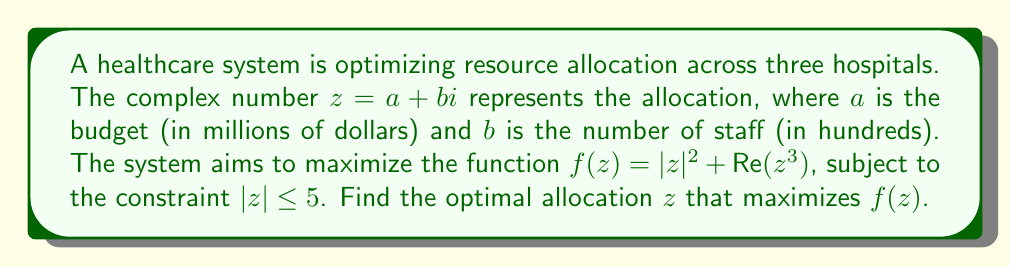Teach me how to tackle this problem. To solve this optimization problem, we'll follow these steps:

1) The function to maximize is $f(z) = |z|^2 + \text{Re}(z^3)$.

2) We can express $z$ in polar form: $z = re^{i\theta}$, where $r = |z|$ and $0 \leq r \leq 5$.

3) Substituting this into our function:

   $f(z) = r^2 + \text{Re}(r^3e^{3i\theta}) = r^2 + r^3\cos(3\theta)$

4) To find the maximum, we need to find the critical points by taking partial derivatives:

   $\frac{\partial f}{\partial r} = 2r + 3r^2\cos(3\theta) = 0$
   $\frac{\partial f}{\partial \theta} = -3r^3\sin(3\theta) = 0$

5) From the second equation, either $r = 0$ (which is not optimal) or $\sin(3\theta) = 0$. This means $3\theta = 0, \pi, 2\pi, ...$, or $\theta = 0, \frac{\pi}{3}, \frac{2\pi}{3}, \pi, ...$

6) When $\theta = 0$ or $\pi$, $\cos(3\theta) = 1$. When $\theta = \frac{\pi}{3}$ or $\frac{2\pi}{3}$, $\cos(3\theta) = -1$.

7) Substituting these into the first equation:

   For $\cos(3\theta) = 1$: $2r + 3r^2 = 0$, or $r(2 + 3r) = 0$, so $r = 0$ or $r = \frac{2}{3}$
   For $\cos(3\theta) = -1$: $2r - 3r^2 = 0$, or $r(2 - 3r) = 0$, so $r = 0$ or $r = \frac{2}{3}$

8) We also need to check the boundary condition $r = 5$.

9) Evaluating $f(z)$ at these points:

   $f(0) = 0$
   $f(\frac{2}{3}) = (\frac{2}{3})^2 + (\frac{2}{3})^3 = \frac{4}{9} + \frac{8}{27} = \frac{20}{27} \approx 0.74$
   $f(\frac{2}{3}e^{i\pi}) = (\frac{2}{3})^2 - (\frac{2}{3})^3 = \frac{4}{9} - \frac{8}{27} = \frac{4}{27} \approx 0.15$
   $f(5) = 25 + 125\cos(3\theta)$, which is maximized when $\cos(3\theta) = 1$, giving $f(5) = 150$

10) The maximum value occurs when $r = 5$ and $\theta = 0$.

Therefore, the optimal allocation is $z = 5 + 0i$.
Answer: The optimal allocation is $z = 5 + 0i$, representing a budget of $5 million and no additional staff. 